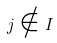Convert formula to latex. <formula><loc_0><loc_0><loc_500><loc_500>j \notin I</formula> 